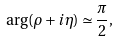<formula> <loc_0><loc_0><loc_500><loc_500>\arg ( \rho + { i } \eta ) \simeq \frac { \pi } { 2 } ,</formula> 